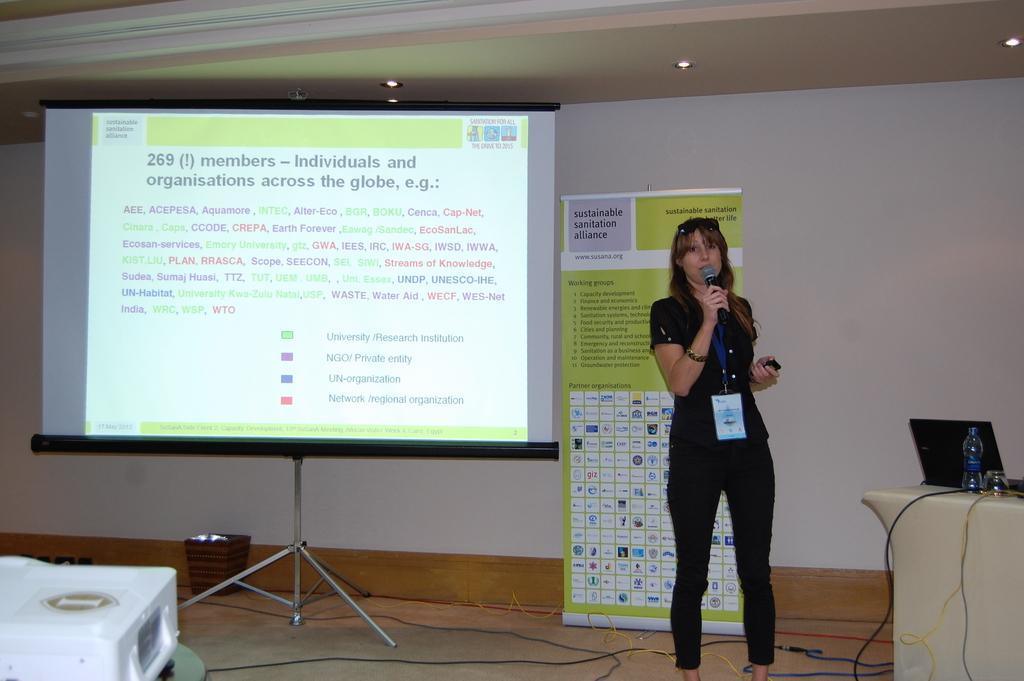How would you summarize this image in a sentence or two? In this image we can see a woman is standing. She is wearing black color dress, ID card in her neck and holding mic in her hand. Behind her, one banner and screen is there. To the right bottom of the image one table is there. on table bottles, laptop and wires are there. To the left bottom of the image, projector is there. Behind the screen, one dustbin is present and wires are there on the floor. 